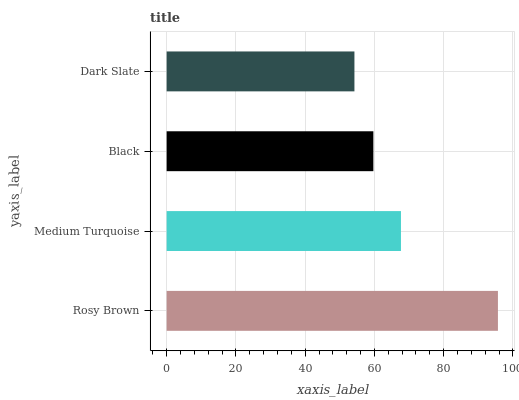Is Dark Slate the minimum?
Answer yes or no. Yes. Is Rosy Brown the maximum?
Answer yes or no. Yes. Is Medium Turquoise the minimum?
Answer yes or no. No. Is Medium Turquoise the maximum?
Answer yes or no. No. Is Rosy Brown greater than Medium Turquoise?
Answer yes or no. Yes. Is Medium Turquoise less than Rosy Brown?
Answer yes or no. Yes. Is Medium Turquoise greater than Rosy Brown?
Answer yes or no. No. Is Rosy Brown less than Medium Turquoise?
Answer yes or no. No. Is Medium Turquoise the high median?
Answer yes or no. Yes. Is Black the low median?
Answer yes or no. Yes. Is Dark Slate the high median?
Answer yes or no. No. Is Medium Turquoise the low median?
Answer yes or no. No. 